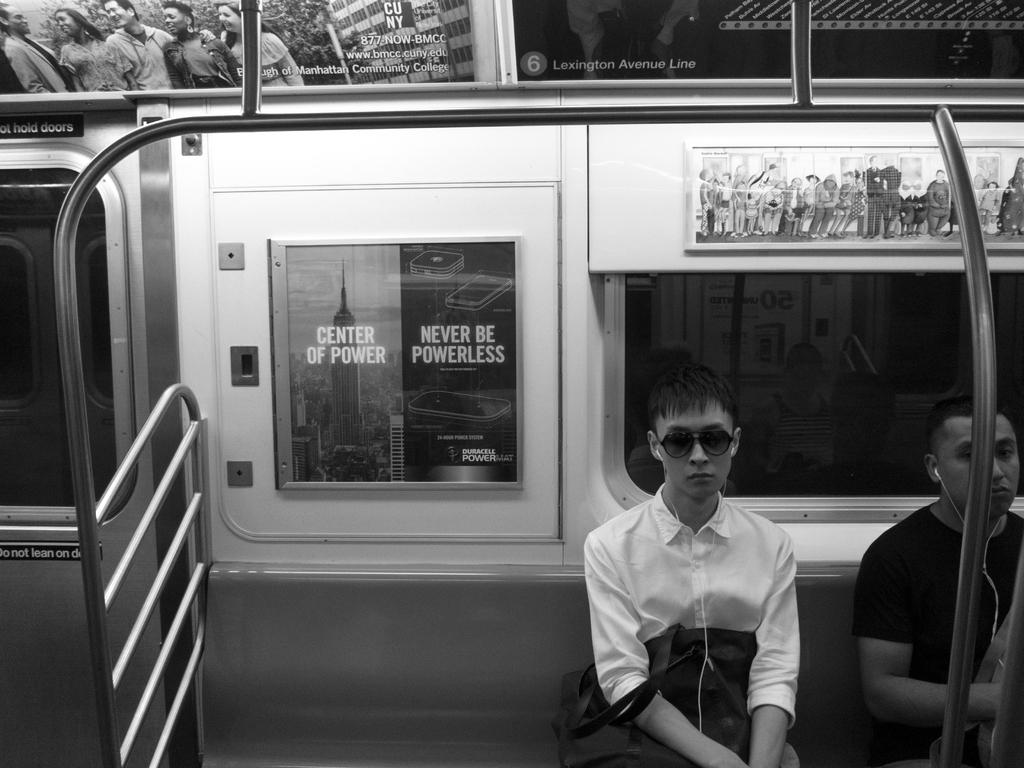How many people are in the image? There are two persons in the image. Where are the two persons located? The two persons are inside a vehicle. What are the persons wearing? The persons are wearing clothes. What type of horn can be seen in the image? There is no horn present in the image. Is the vehicle in the image hot or cold? The image does not provide information about the temperature inside the vehicle. 